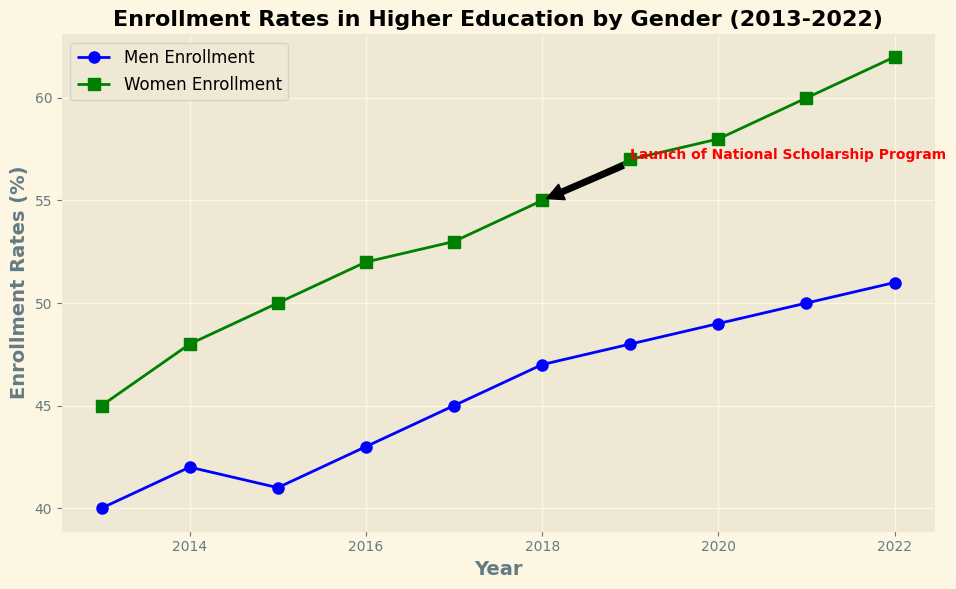What significant event is annotated in the chart regarding higher education enrollment? The annotation on the chart indicates the launch of a National Scholarship Program in 2018, which may have impacted enrollment trends.
Answer: Launch of National Scholarship Program In which year did the enrollment rate for women surpass the 50% mark? The chart shows that the enrollment rate for women surpassed the 50% mark in 2015.
Answer: 2015 How does the enrollment rate for men in 2013 compare to that in 2022? The enrollment rate for men in 2013 was 40%, while in 2022 it was 51%, indicating an increase over the decade.
Answer: Increased from 40% to 51% What is the difference in the enrollment rates between men and women in 2022? In 2022, the enrollment rate for men is 51% and for women is 62%. The difference is 62% - 51% = 11%.
Answer: 11% Which gender had a higher increase in enrollment rate from 2013 to 2022? From 2013 to 2022, men's enrollment increased from 40% to 51% (an 11% increase), while women's enrollment increased from 45% to 62% (a 17% increase). Therefore, women had a higher increase in enrollment rate.
Answer: Women What general trend can be observed in the enrollment rates for both men and women from 2013 to 2022? Both the enrollment rates for men and women showed a steady increase from 2013 to 2022 according to the line chart.
Answer: Steady increase How did the launch of the National Scholarship Program seem to impact the enrollment rates for women? Following the launch of the National Scholarship Program in 2018, there is a noticeable increase in the enrollment rate for women from 55% in 2018 to 57% in 2019, suggesting a positive impact.
Answer: Positively What is the average annual increase in enrollment rates for women from 2013 to 2022? The enrollment rate for women increased from 45% in 2013 to 62% in 2022. The average annual increase is (62 - 45) / (2022 - 2013) = 17 / 9 ≈ 1.89%.
Answer: Approximately 1.89% Which year showed the smallest increase in enrollment rate for men compared to the previous year? Between 2014 and 2015, the enrollment rate for men increased by just 1% (42% to 43%), which is the smallest increase compared to other years.
Answer: 2015 Describe how the enrollment rates for men and women compare overall during the decade. Throughout the decade, women consistently had higher enrollment rates compared to men, with a noticeable gap that widened over the years.
Answer: Women consistently higher 